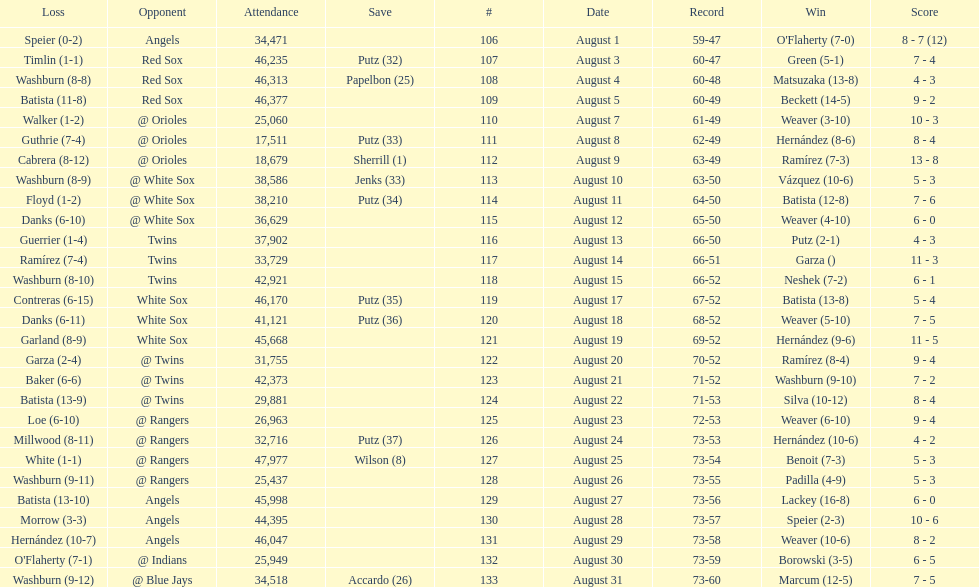Number of wins during stretch 5. 